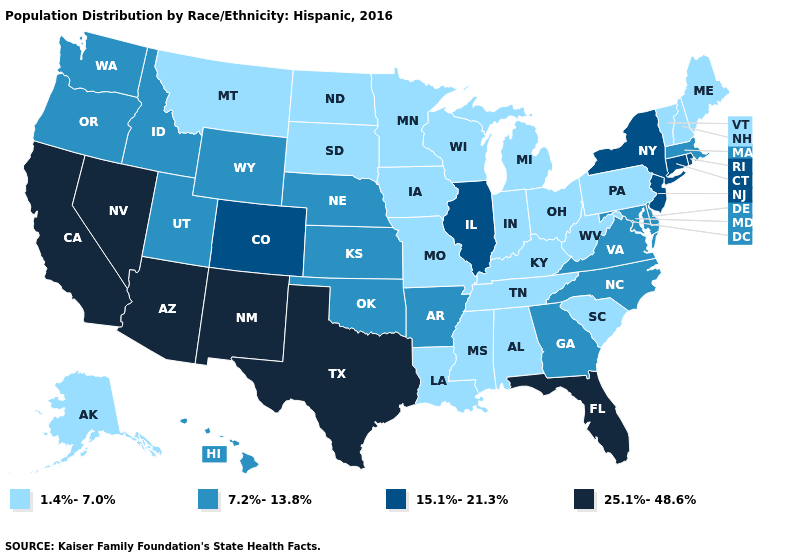Does Kentucky have the highest value in the USA?
Concise answer only. No. What is the highest value in states that border Delaware?
Quick response, please. 15.1%-21.3%. Does the first symbol in the legend represent the smallest category?
Give a very brief answer. Yes. What is the value of Florida?
Keep it brief. 25.1%-48.6%. What is the value of South Carolina?
Be succinct. 1.4%-7.0%. Among the states that border West Virginia , does Maryland have the highest value?
Short answer required. Yes. Name the states that have a value in the range 1.4%-7.0%?
Answer briefly. Alabama, Alaska, Indiana, Iowa, Kentucky, Louisiana, Maine, Michigan, Minnesota, Mississippi, Missouri, Montana, New Hampshire, North Dakota, Ohio, Pennsylvania, South Carolina, South Dakota, Tennessee, Vermont, West Virginia, Wisconsin. What is the value of Georgia?
Quick response, please. 7.2%-13.8%. Does Maryland have the same value as Florida?
Short answer required. No. What is the lowest value in the MidWest?
Concise answer only. 1.4%-7.0%. What is the lowest value in states that border Montana?
Be succinct. 1.4%-7.0%. Name the states that have a value in the range 25.1%-48.6%?
Write a very short answer. Arizona, California, Florida, Nevada, New Mexico, Texas. What is the value of New York?
Write a very short answer. 15.1%-21.3%. What is the value of Florida?
Give a very brief answer. 25.1%-48.6%. Name the states that have a value in the range 25.1%-48.6%?
Give a very brief answer. Arizona, California, Florida, Nevada, New Mexico, Texas. 